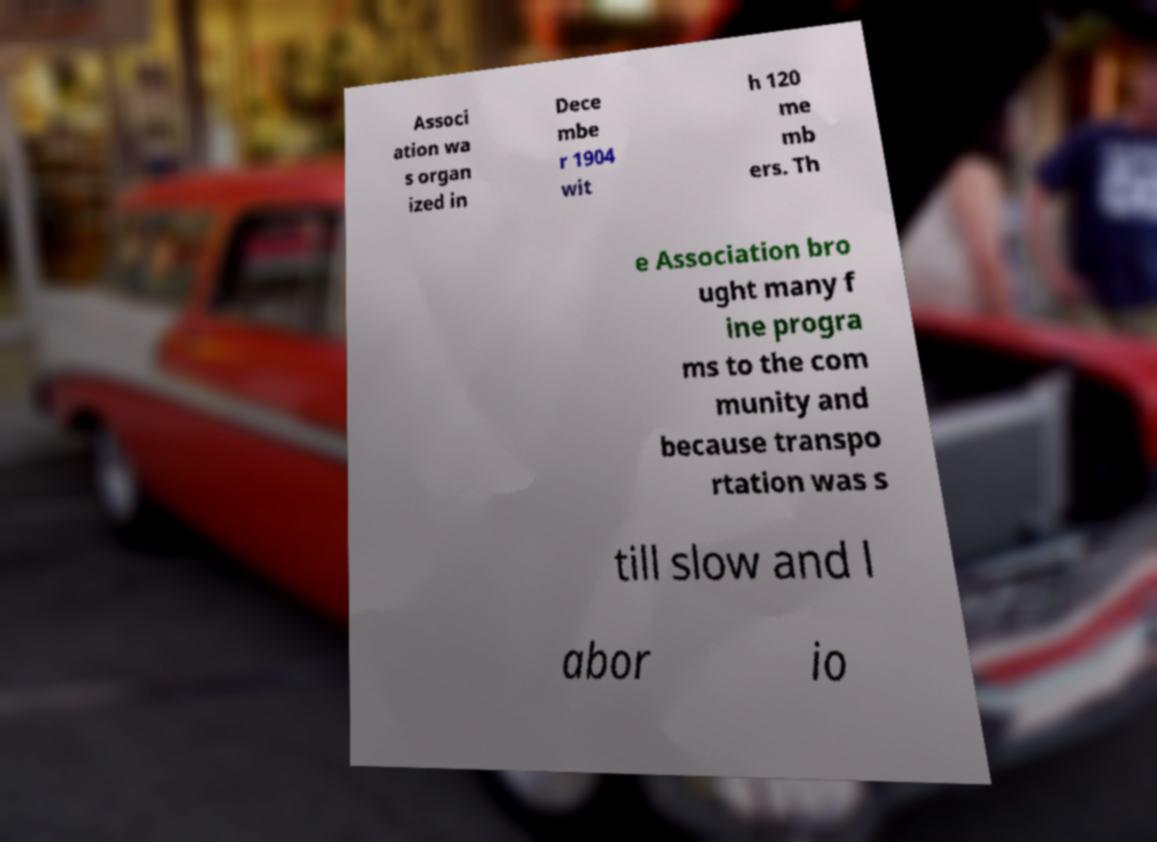Please identify and transcribe the text found in this image. Associ ation wa s organ ized in Dece mbe r 1904 wit h 120 me mb ers. Th e Association bro ught many f ine progra ms to the com munity and because transpo rtation was s till slow and l abor io 